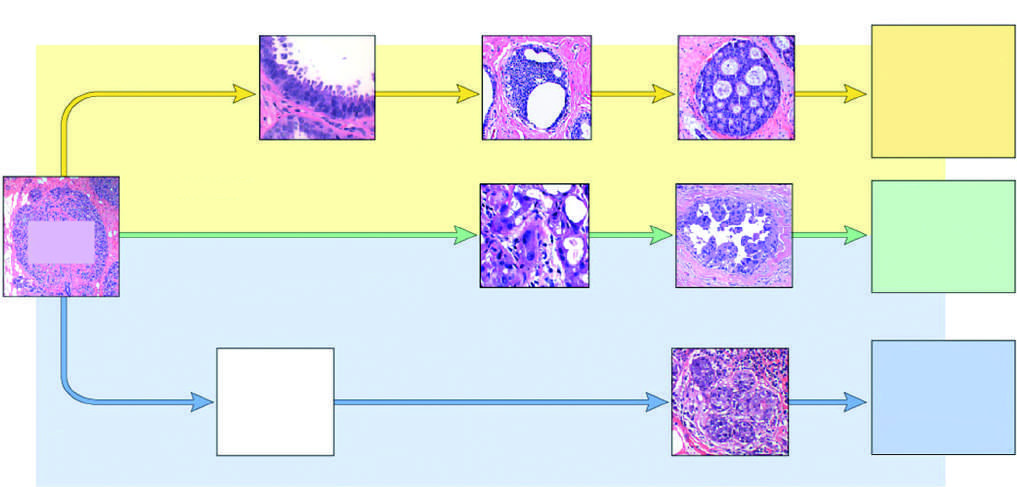what leads to er-positive cancers?
Answer the question using a single word or phrase. The most common pathway 